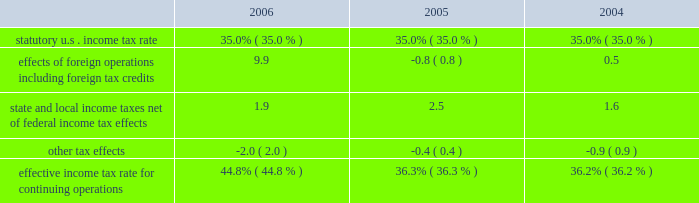For additional information on segment results see page 43 .
Income from equity method investments increased by $ 126 million in 2006 from 2005 and increased by $ 98 million in 2005 from 2004 .
Income from our lpg operations in equatorial guinea increased in both periods due to higher sales volumes as a result of the plant expansions completed in 2005 .
The increase in 2005 also included higher ptc income as a result of higher distillate gross margins .
Cost of revenues increased $ 4.609 billion in 2006 from 2005 and $ 7.106 billion in 2005 from 2004 .
In both periods the increases were primarily in the rm&t segment and resulted from increases in acquisition costs of crude oil , refinery charge and blend stocks and purchased refined products .
The increase in both periods was also impacted by higher manufacturing expenses , primarily the result of higher contract services and labor costs in 2006 and higher purchased energy costs in 2005 .
Purchases related to matching buy/sell transactions decreased $ 6.968 billion in 2006 from 2005 and increased $ 3.314 billion in 2005 from 2004 , mostly in the rm&t segment .
The decrease in 2006 was primarily related to the change in accounting for matching buy/sell transactions discussed above .
The increase in 2005 was primarily due to increased crude oil prices .
Depreciation , depletion and amortization increased $ 215 million in 2006 from 2005 and $ 125 million in 2005 from 2004 .
Rm&t segment depreciation expense increased in both years as a result of the increase in asset value recorded for our acquisition of the 38 percent interest in mpc on june 30 , 2005 .
In addition , the detroit refinery expansion completed in the fourth quarter of 2005 contributed to the rm&t depreciation expense increase in 2006 .
E&p segment depreciation expense for 2006 included a $ 20 million impairment of capitalized costs related to the camden hills field in the gulf of mexico and the associated canyon express pipeline .
Natural gas production from the camden hills field ended in 2006 as a result of increased water production from the well .
Selling , general and administrative expenses increased $ 73 million in 2006 from 2005 and $ 134 million in 2005 from 2004 .
The 2006 increase was primarily because personnel and staffing costs increased throughout the year primarily as a result of variable compensation arrangements and increased business activity .
Partially offsetting these increases were reductions in stock-based compensation expense .
The increase in 2005 was primarily a result of increased stock-based compensation expense , due to the increase in our stock price during that year as well as an increase in equity-based awards , which was partially offset by a decrease in expense as a result of severance and pension plan curtailment charges and start-up costs related to egholdings in 2004 .
Exploration expenses increased $ 148 million in 2006 from 2005 and $ 59 million in 2005 from 2004 .
Exploration expense related to dry wells and other write-offs totaled $ 166 million , $ 111 million and $ 47 million in 2006 , 2005 and 2004 .
Exploration expense in 2006 also included $ 47 million for exiting the cortland and empire leases in nova scotia .
Net interest and other financing costs ( income ) reflected a net $ 37 million of income for 2006 , a favorable change of $ 183 million from the net $ 146 million expense in 2005 .
Net interest and other financing costs decreased $ 16 million in 2005 from 2004 .
The favorable changes in 2006 included increased interest income due to higher interest rates and average cash balances , foreign currency exchange gains , adjustments to interest on tax issues and greater capitalized interest .
The decrease in expense for 2005 was primarily a result of increased interest income on higher average cash balances and greater capitalized interest , partially offset by increased interest on potential tax deficiencies and higher foreign exchange losses .
Included in net interest and other financing costs ( income ) are foreign currency gains of $ 16 million , losses of $ 17 million and gains of $ 9 million for 2006 , 2005 and 2004 .
Minority interest in income of mpc decreased $ 148 million in 2005 from 2004 due to our acquisition of the 38 percent interest in mpc on june 30 , 2005 .
Provision for income taxes increased $ 2.308 billion in 2006 from 2005 and $ 979 million in 2005 from 2004 , primarily due to the $ 4.259 billion and $ 2.691 billion increases in income from continuing operations before income taxes .
The increase in our effective income tax rate in 2006 was primarily a result of the income taxes related to our libyan operations , where the statutory income tax rate is in excess of 90 percent .
The following is an analysis of the effective income tax rates for continuing operations for 2006 , 2005 and 2004 .
See note 11 to the consolidated financial statements for further discussion. .

Included in net interest and other financing costs ( income ) , what were total foreign currency gains ( millions ) for 2006 , 2005 and 2004? 
Computations: ((16 + 17) + 9)
Answer: 42.0. 